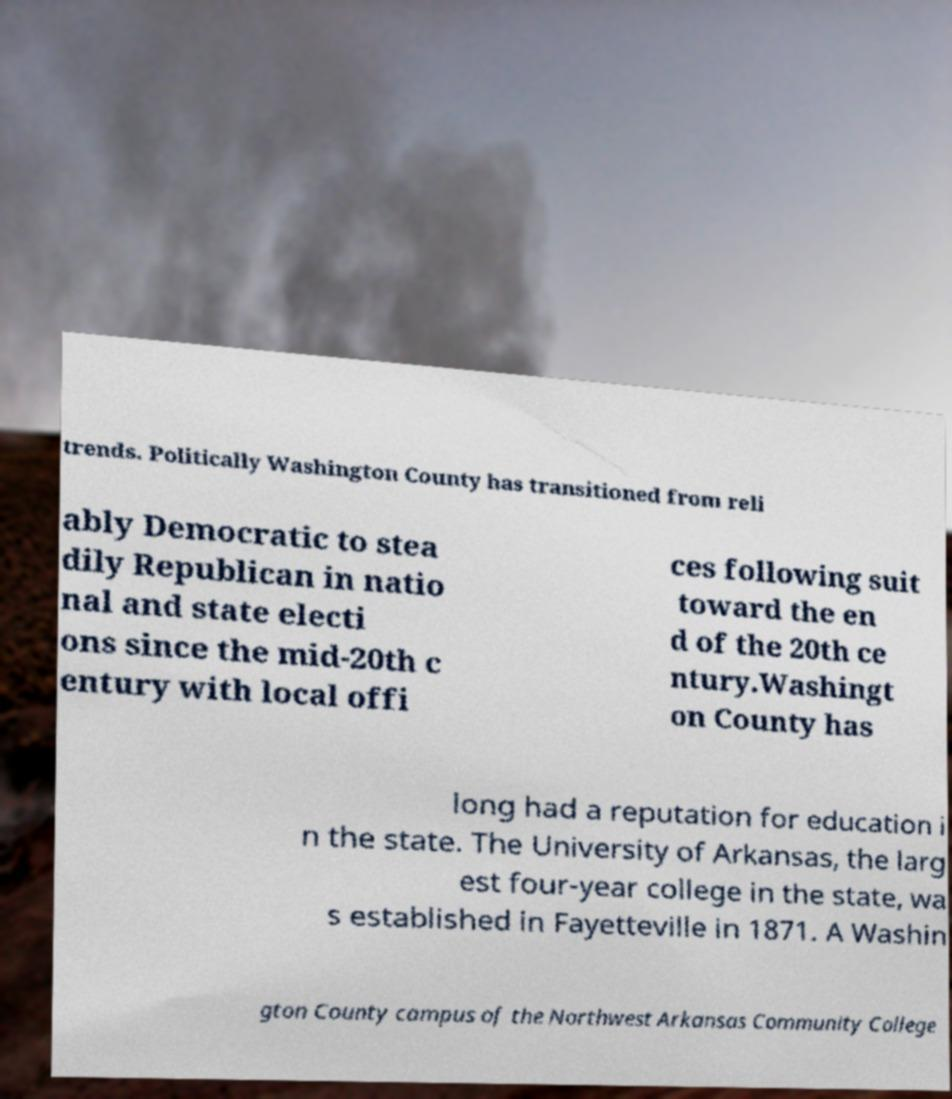There's text embedded in this image that I need extracted. Can you transcribe it verbatim? trends. Politically Washington County has transitioned from reli ably Democratic to stea dily Republican in natio nal and state electi ons since the mid-20th c entury with local offi ces following suit toward the en d of the 20th ce ntury.Washingt on County has long had a reputation for education i n the state. The University of Arkansas, the larg est four-year college in the state, wa s established in Fayetteville in 1871. A Washin gton County campus of the Northwest Arkansas Community College 